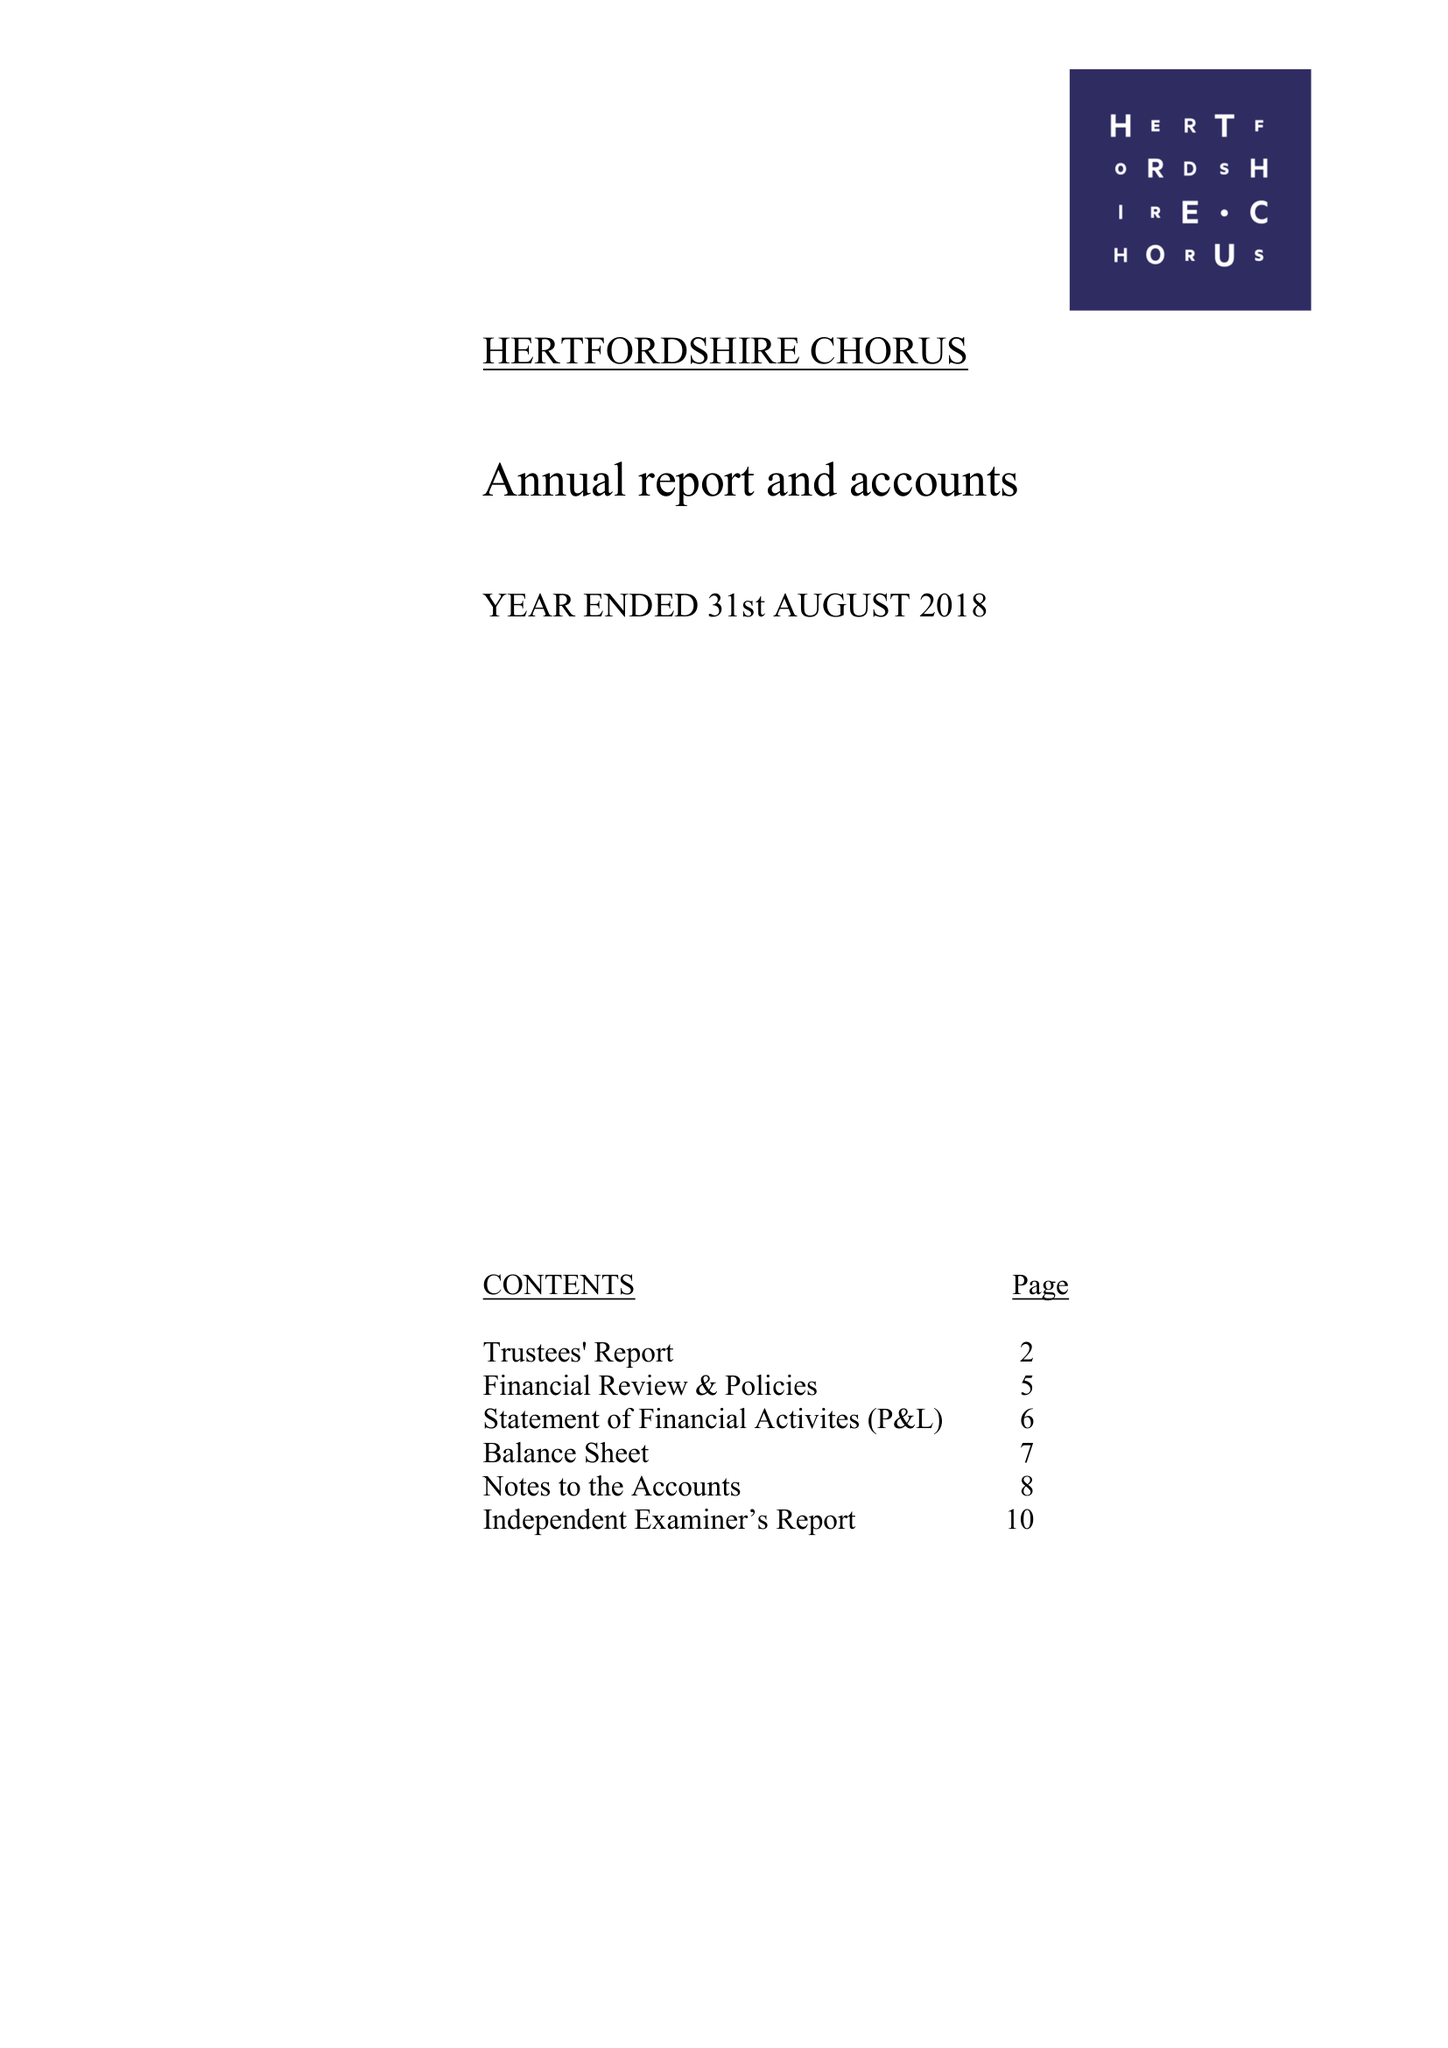What is the value for the address__street_line?
Answer the question using a single word or phrase. 16 BARNCROFT WAY 